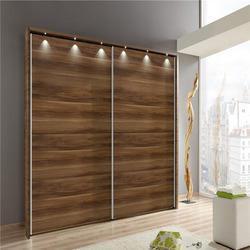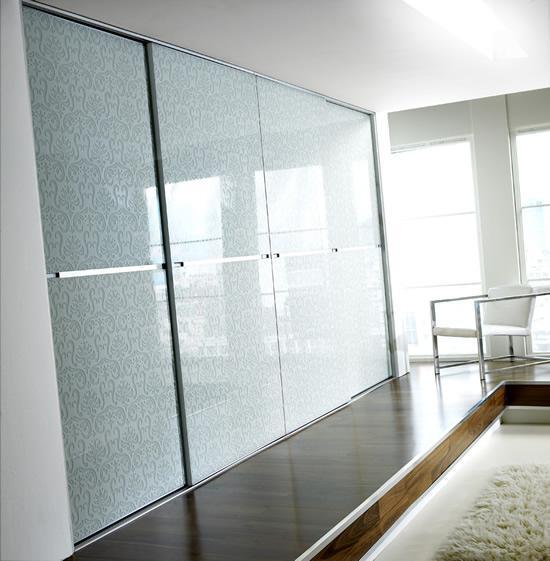The first image is the image on the left, the second image is the image on the right. Evaluate the accuracy of this statement regarding the images: "A cushioned chair sits outside a door in the image on the left.". Is it true? Answer yes or no. No. The first image is the image on the left, the second image is the image on the right. Given the left and right images, does the statement "One closet's doors has a photographic image design." hold true? Answer yes or no. No. 